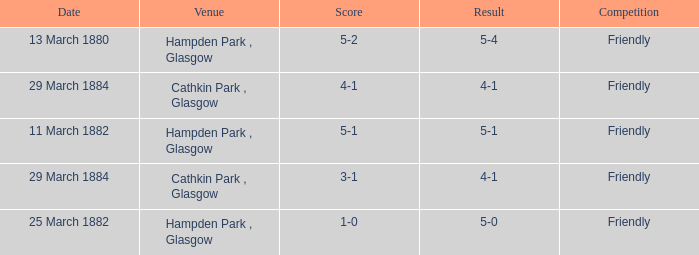Which item resulted in a score of 4-1? 3-1, 4-1. Help me parse the entirety of this table. {'header': ['Date', 'Venue', 'Score', 'Result', 'Competition'], 'rows': [['13 March 1880', 'Hampden Park , Glasgow', '5-2', '5-4', 'Friendly'], ['29 March 1884', 'Cathkin Park , Glasgow', '4-1', '4-1', 'Friendly'], ['11 March 1882', 'Hampden Park , Glasgow', '5-1', '5-1', 'Friendly'], ['29 March 1884', 'Cathkin Park , Glasgow', '3-1', '4-1', 'Friendly'], ['25 March 1882', 'Hampden Park , Glasgow', '1-0', '5-0', 'Friendly']]} 